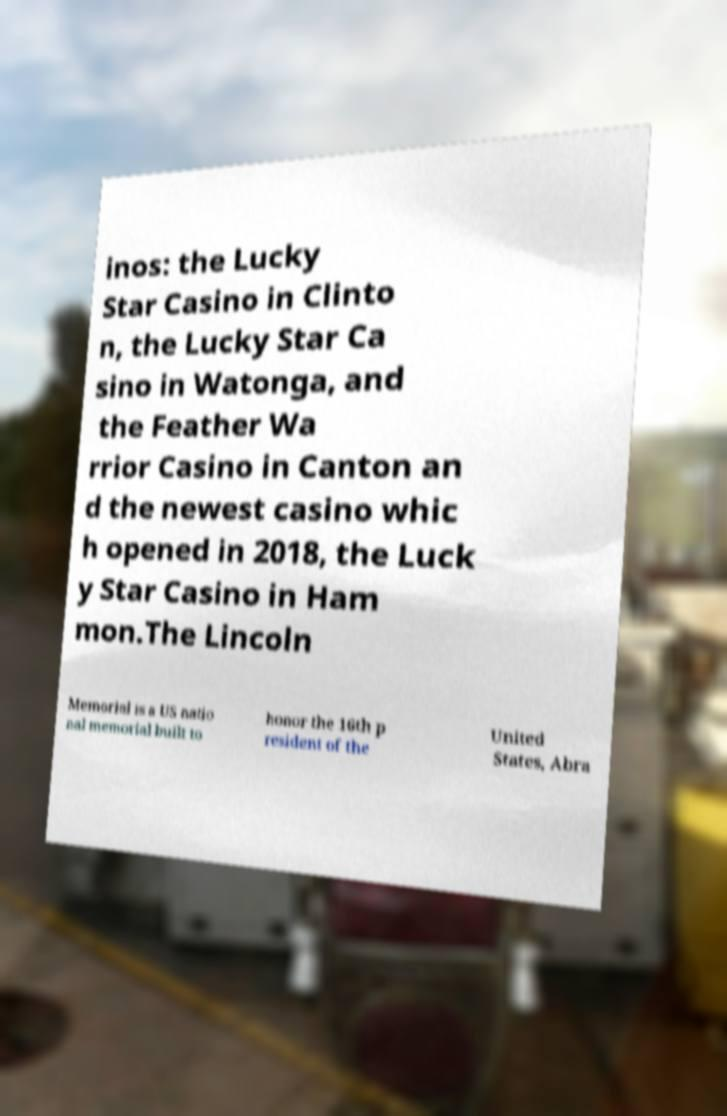For documentation purposes, I need the text within this image transcribed. Could you provide that? inos: the Lucky Star Casino in Clinto n, the Lucky Star Ca sino in Watonga, and the Feather Wa rrior Casino in Canton an d the newest casino whic h opened in 2018, the Luck y Star Casino in Ham mon.The Lincoln Memorial is a US natio nal memorial built to honor the 16th p resident of the United States, Abra 